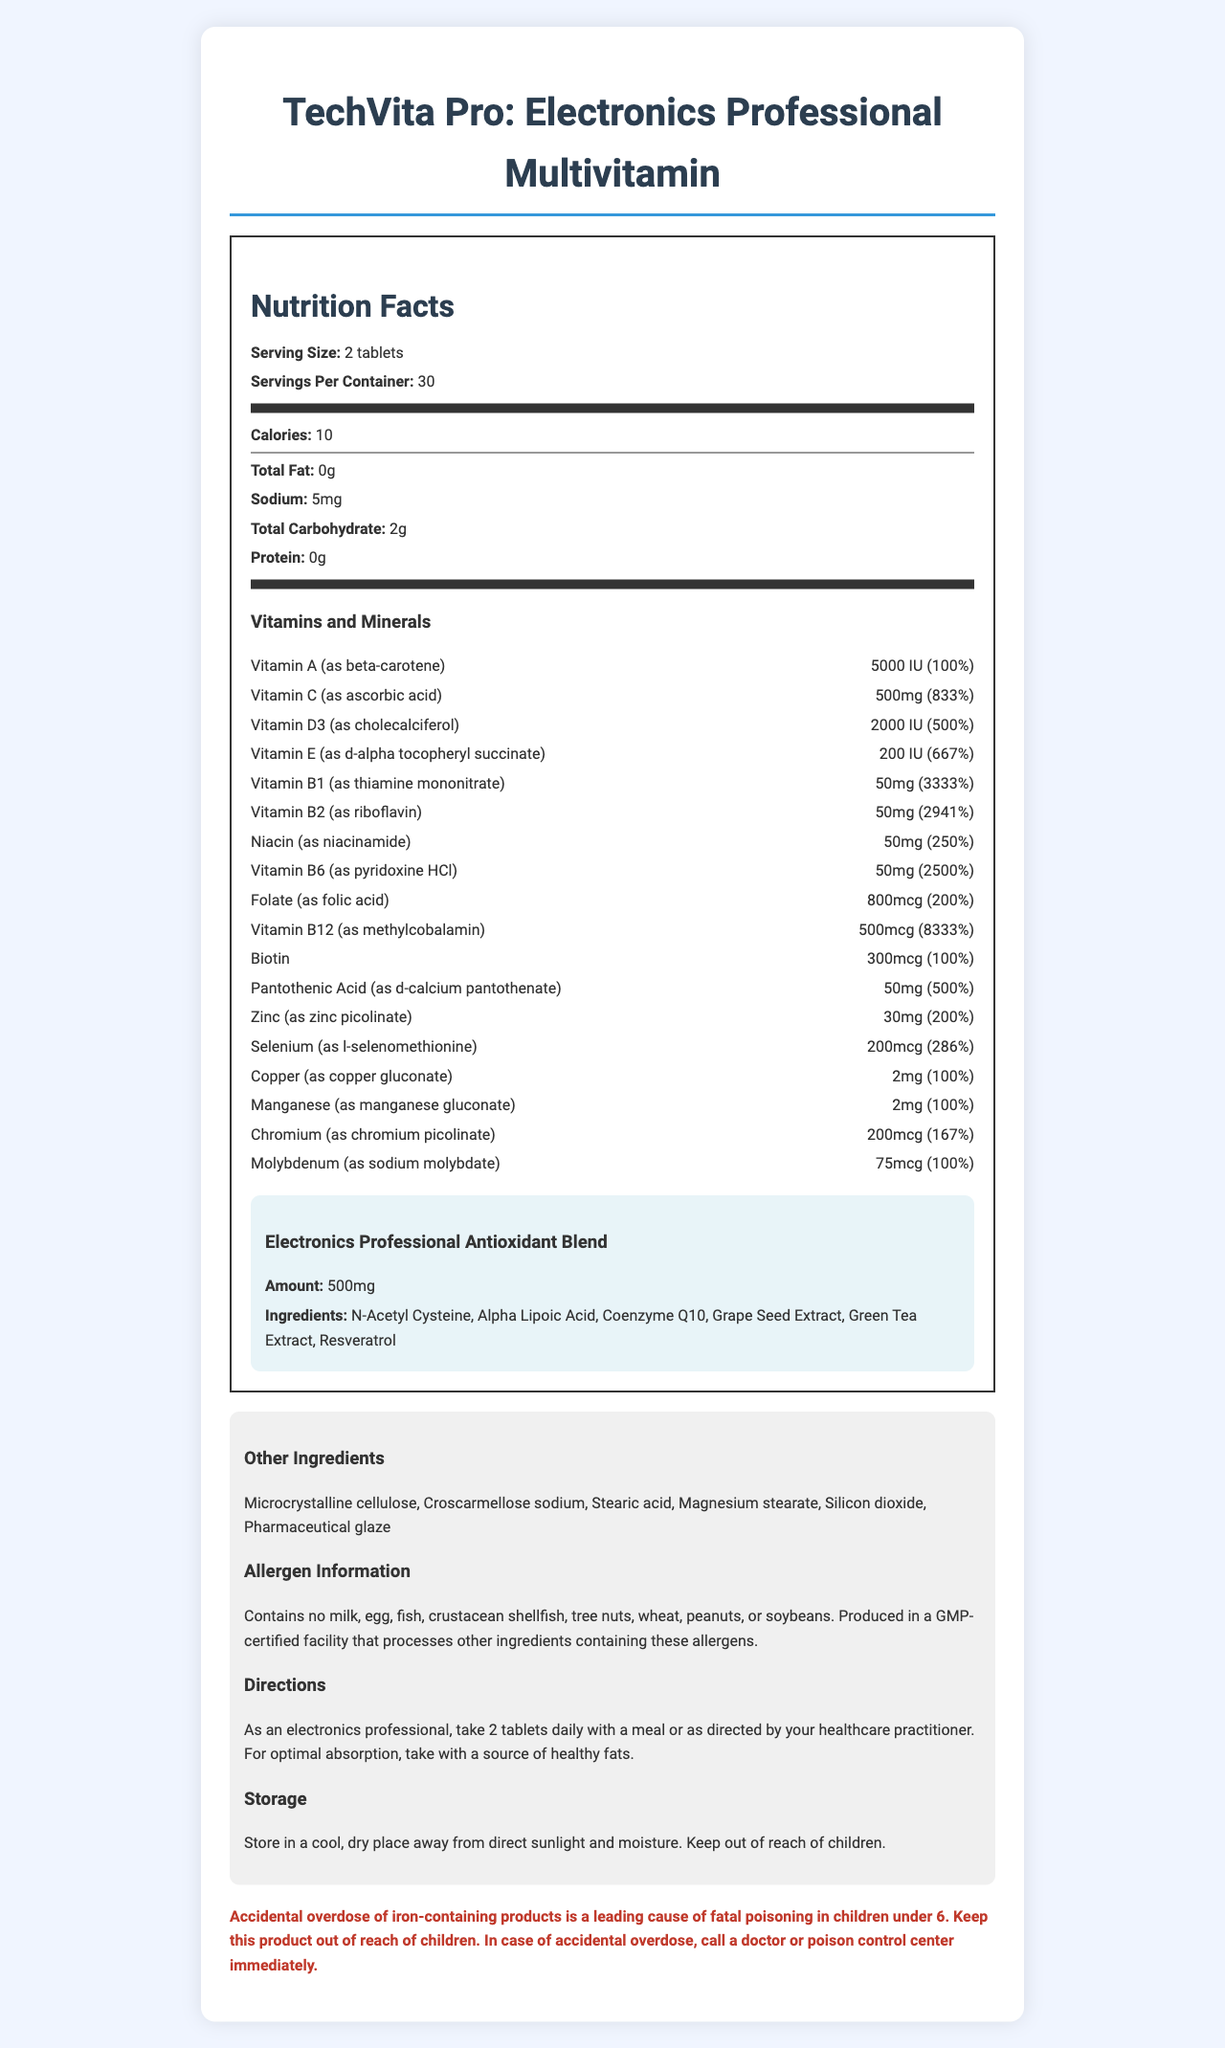what is the serving size for TechVita Pro? The document lists the serving size as "2 tablets".
Answer: 2 tablets how many calories are in one serving? The document states that there are 10 calories per serving.
Answer: 10 how many servings are there per container? The document mentions that there are 30 servings per container.
Answer: 30 what is the amount of Vitamin C per serving? The document specifies that Vitamin C is 500mg per serving and provides 833% of the daily value.
Answer: 500mg (833%) are there any proteins in TechVita Pro? The document states that the protein content is "0g".
Answer: No which vitamin has the highest daily value percentage? A. Vitamin B1 B. Vitamin B2 C. Vitamin B12 D. Vitamin D3 Vitamin B12 has a daily value of 8333%, which is higher than the daily values of the other vitamins listed.
Answer: C. Vitamin B12 how much Zinc is there in one serving? The document states that one serving contains 30mg of Zinc, which is 200% of the daily value.
Answer: 30mg (200%) what proprietary blend is included in this supplement? The document describes the proprietary blend as the "Electronics Professional Antioxidant Blend".
Answer: Electronics Professional Antioxidant Blend what amount of iodine does this supplement contain? The document does not list iodine among its vitamins and minerals, hence this information is unavailable.
Answer: Not enough information does TechVita Pro contain tree nuts? The document states in the allergen information that the product contains no tree nuts.
Answer: No what should be done in case of accidental overdose in children under 6? The warning section of the document advises to call a doctor or poison control center immediately in case of accidental overdose in children under 6.
Answer: Call a doctor or poison control center immediately list three ingredients found in the Electronics Professional Antioxidant Blend. The document lists these ingredients as part of the proprietary blend.
Answer: N-Acetyl Cysteine, Alpha Lipoic Acid, Coenzyme Q10 summarize the main content of the document The document provides comprehensive details about the product, including nutritional information, recommended usage, and safety precautions.
Answer: TechVita Pro is a specialized multivitamin tailored for electronics professionals, containing detailed nutrition facts, serving size, vitamins, minerals, a proprietary antioxidant blend, other ingredients, allergen information, usage directions, storage instructions, and a safety warning. 